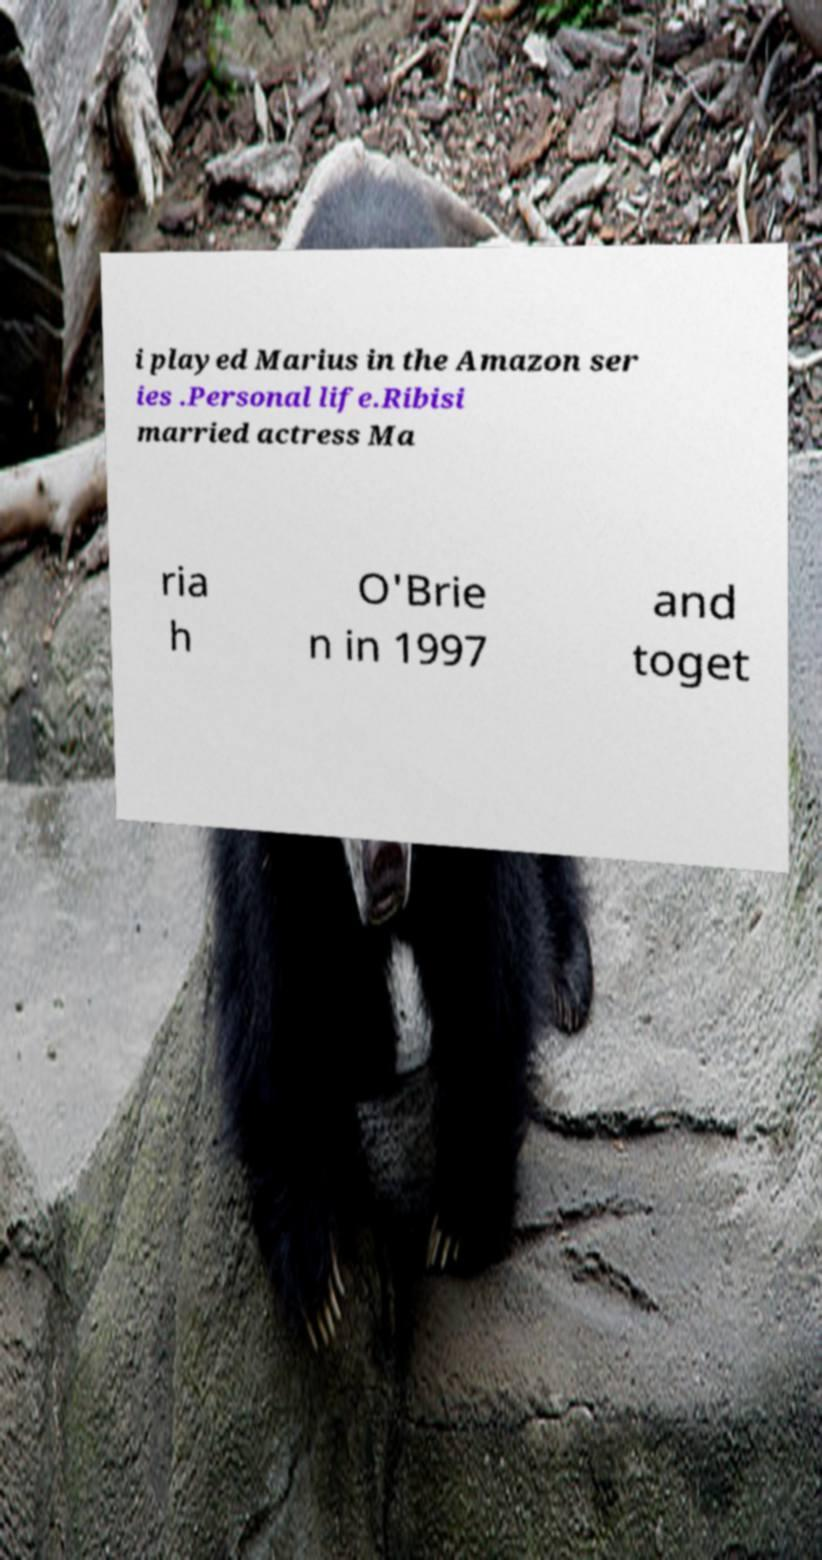There's text embedded in this image that I need extracted. Can you transcribe it verbatim? i played Marius in the Amazon ser ies .Personal life.Ribisi married actress Ma ria h O'Brie n in 1997 and toget 